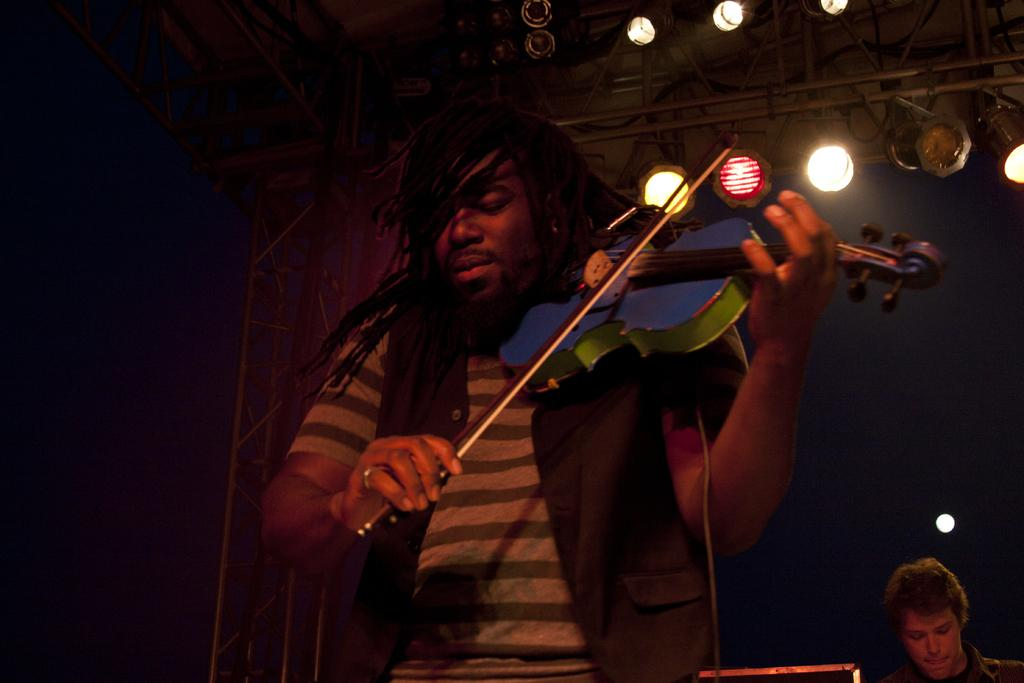What is the man in the image holding? The man is holding a violin. Can you describe the person in the background of the image? There is a person in the background of the image, but no specific details are provided. What can be seen in the background of the image? There are lights and some objects visible in the background. How would you describe the lighting conditions in the background? The background appears to be dark. What type of can is visible in the image? There is no can present in the image. Can you describe the patch on the man's clothing in the image? There is no mention of a patch on the man's clothing in the provided facts. 